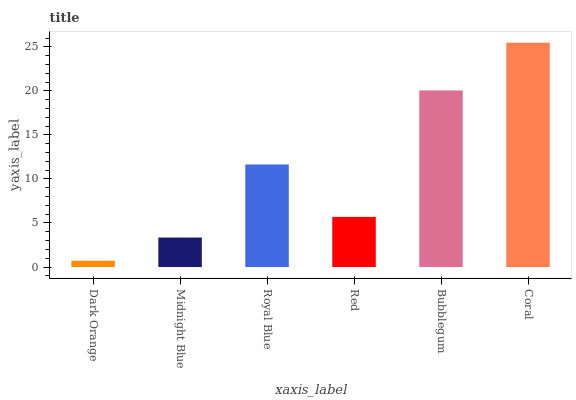Is Dark Orange the minimum?
Answer yes or no. Yes. Is Coral the maximum?
Answer yes or no. Yes. Is Midnight Blue the minimum?
Answer yes or no. No. Is Midnight Blue the maximum?
Answer yes or no. No. Is Midnight Blue greater than Dark Orange?
Answer yes or no. Yes. Is Dark Orange less than Midnight Blue?
Answer yes or no. Yes. Is Dark Orange greater than Midnight Blue?
Answer yes or no. No. Is Midnight Blue less than Dark Orange?
Answer yes or no. No. Is Royal Blue the high median?
Answer yes or no. Yes. Is Red the low median?
Answer yes or no. Yes. Is Bubblegum the high median?
Answer yes or no. No. Is Bubblegum the low median?
Answer yes or no. No. 